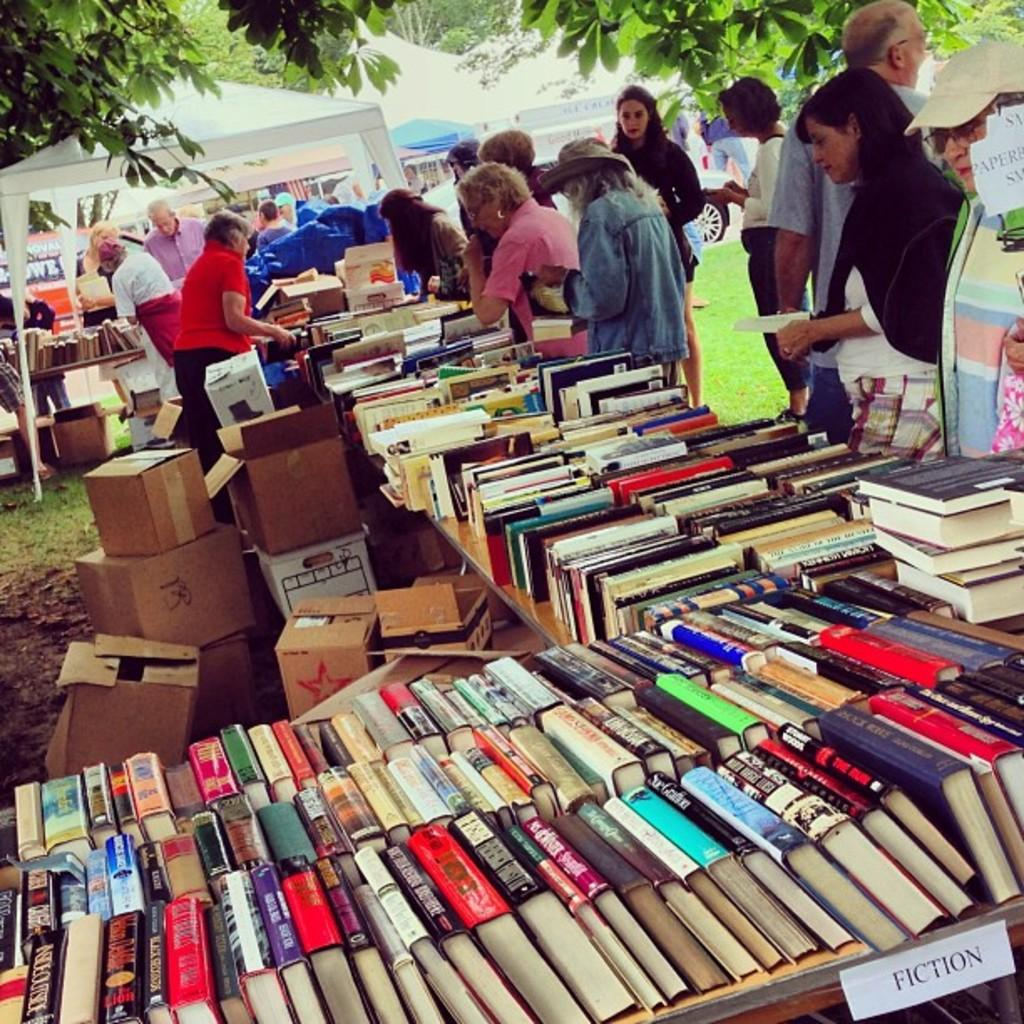Provide a one-sentence caption for the provided image. Several book spines are viewable on a table at a sale with the description of FICTION. 